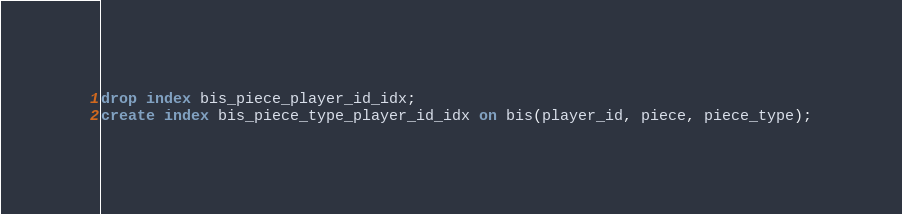<code> <loc_0><loc_0><loc_500><loc_500><_SQL_>drop index bis_piece_player_id_idx;
create index bis_piece_type_player_id_idx on bis(player_id, piece, piece_type);</code> 